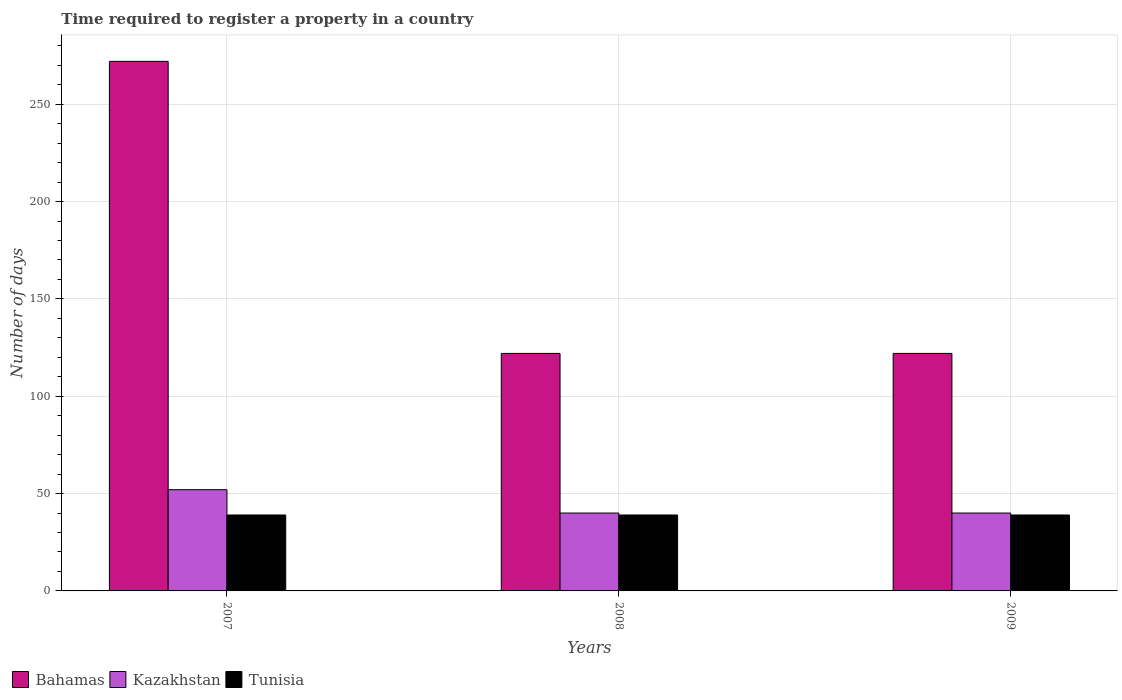How many different coloured bars are there?
Give a very brief answer. 3. How many bars are there on the 1st tick from the left?
Provide a short and direct response. 3. What is the number of days required to register a property in Kazakhstan in 2008?
Provide a short and direct response. 40. Across all years, what is the maximum number of days required to register a property in Bahamas?
Make the answer very short. 272. Across all years, what is the minimum number of days required to register a property in Tunisia?
Provide a short and direct response. 39. What is the total number of days required to register a property in Bahamas in the graph?
Provide a short and direct response. 516. What is the difference between the number of days required to register a property in Bahamas in 2007 and that in 2008?
Your answer should be compact. 150. In the year 2007, what is the difference between the number of days required to register a property in Bahamas and number of days required to register a property in Kazakhstan?
Provide a succinct answer. 220. In how many years, is the number of days required to register a property in Kazakhstan greater than 200 days?
Offer a very short reply. 0. What is the ratio of the number of days required to register a property in Bahamas in 2007 to that in 2009?
Your answer should be very brief. 2.23. Is the number of days required to register a property in Tunisia in 2008 less than that in 2009?
Keep it short and to the point. No. Is the difference between the number of days required to register a property in Bahamas in 2007 and 2008 greater than the difference between the number of days required to register a property in Kazakhstan in 2007 and 2008?
Keep it short and to the point. Yes. What is the difference between the highest and the lowest number of days required to register a property in Bahamas?
Keep it short and to the point. 150. In how many years, is the number of days required to register a property in Kazakhstan greater than the average number of days required to register a property in Kazakhstan taken over all years?
Your response must be concise. 1. What does the 1st bar from the left in 2009 represents?
Offer a very short reply. Bahamas. What does the 3rd bar from the right in 2008 represents?
Provide a short and direct response. Bahamas. Are all the bars in the graph horizontal?
Your response must be concise. No. Are the values on the major ticks of Y-axis written in scientific E-notation?
Your answer should be compact. No. Where does the legend appear in the graph?
Provide a succinct answer. Bottom left. How many legend labels are there?
Your answer should be very brief. 3. What is the title of the graph?
Your response must be concise. Time required to register a property in a country. Does "Solomon Islands" appear as one of the legend labels in the graph?
Your answer should be compact. No. What is the label or title of the X-axis?
Provide a succinct answer. Years. What is the label or title of the Y-axis?
Your answer should be very brief. Number of days. What is the Number of days of Bahamas in 2007?
Your answer should be compact. 272. What is the Number of days in Kazakhstan in 2007?
Offer a very short reply. 52. What is the Number of days in Bahamas in 2008?
Provide a succinct answer. 122. What is the Number of days of Bahamas in 2009?
Your answer should be very brief. 122. What is the Number of days of Kazakhstan in 2009?
Provide a short and direct response. 40. Across all years, what is the maximum Number of days in Bahamas?
Offer a terse response. 272. Across all years, what is the maximum Number of days in Kazakhstan?
Offer a very short reply. 52. Across all years, what is the minimum Number of days of Bahamas?
Your response must be concise. 122. Across all years, what is the minimum Number of days in Kazakhstan?
Give a very brief answer. 40. What is the total Number of days of Bahamas in the graph?
Offer a terse response. 516. What is the total Number of days of Kazakhstan in the graph?
Keep it short and to the point. 132. What is the total Number of days in Tunisia in the graph?
Keep it short and to the point. 117. What is the difference between the Number of days of Bahamas in 2007 and that in 2008?
Give a very brief answer. 150. What is the difference between the Number of days of Bahamas in 2007 and that in 2009?
Give a very brief answer. 150. What is the difference between the Number of days in Kazakhstan in 2007 and that in 2009?
Provide a succinct answer. 12. What is the difference between the Number of days of Tunisia in 2007 and that in 2009?
Make the answer very short. 0. What is the difference between the Number of days in Bahamas in 2008 and that in 2009?
Your response must be concise. 0. What is the difference between the Number of days of Kazakhstan in 2008 and that in 2009?
Provide a short and direct response. 0. What is the difference between the Number of days in Bahamas in 2007 and the Number of days in Kazakhstan in 2008?
Your answer should be compact. 232. What is the difference between the Number of days in Bahamas in 2007 and the Number of days in Tunisia in 2008?
Offer a terse response. 233. What is the difference between the Number of days of Bahamas in 2007 and the Number of days of Kazakhstan in 2009?
Provide a succinct answer. 232. What is the difference between the Number of days in Bahamas in 2007 and the Number of days in Tunisia in 2009?
Your response must be concise. 233. What is the difference between the Number of days of Kazakhstan in 2007 and the Number of days of Tunisia in 2009?
Offer a terse response. 13. What is the difference between the Number of days in Bahamas in 2008 and the Number of days in Tunisia in 2009?
Your answer should be compact. 83. What is the average Number of days in Bahamas per year?
Ensure brevity in your answer.  172. What is the average Number of days in Tunisia per year?
Your answer should be compact. 39. In the year 2007, what is the difference between the Number of days of Bahamas and Number of days of Kazakhstan?
Give a very brief answer. 220. In the year 2007, what is the difference between the Number of days of Bahamas and Number of days of Tunisia?
Provide a short and direct response. 233. In the year 2008, what is the difference between the Number of days of Bahamas and Number of days of Kazakhstan?
Provide a succinct answer. 82. In the year 2008, what is the difference between the Number of days of Bahamas and Number of days of Tunisia?
Make the answer very short. 83. In the year 2008, what is the difference between the Number of days in Kazakhstan and Number of days in Tunisia?
Your answer should be compact. 1. In the year 2009, what is the difference between the Number of days of Bahamas and Number of days of Tunisia?
Provide a succinct answer. 83. What is the ratio of the Number of days in Bahamas in 2007 to that in 2008?
Provide a short and direct response. 2.23. What is the ratio of the Number of days in Bahamas in 2007 to that in 2009?
Your answer should be very brief. 2.23. What is the ratio of the Number of days of Kazakhstan in 2007 to that in 2009?
Your answer should be very brief. 1.3. What is the ratio of the Number of days in Bahamas in 2008 to that in 2009?
Offer a very short reply. 1. What is the ratio of the Number of days of Kazakhstan in 2008 to that in 2009?
Provide a short and direct response. 1. What is the difference between the highest and the second highest Number of days of Bahamas?
Provide a succinct answer. 150. What is the difference between the highest and the second highest Number of days in Tunisia?
Keep it short and to the point. 0. What is the difference between the highest and the lowest Number of days of Bahamas?
Give a very brief answer. 150. 